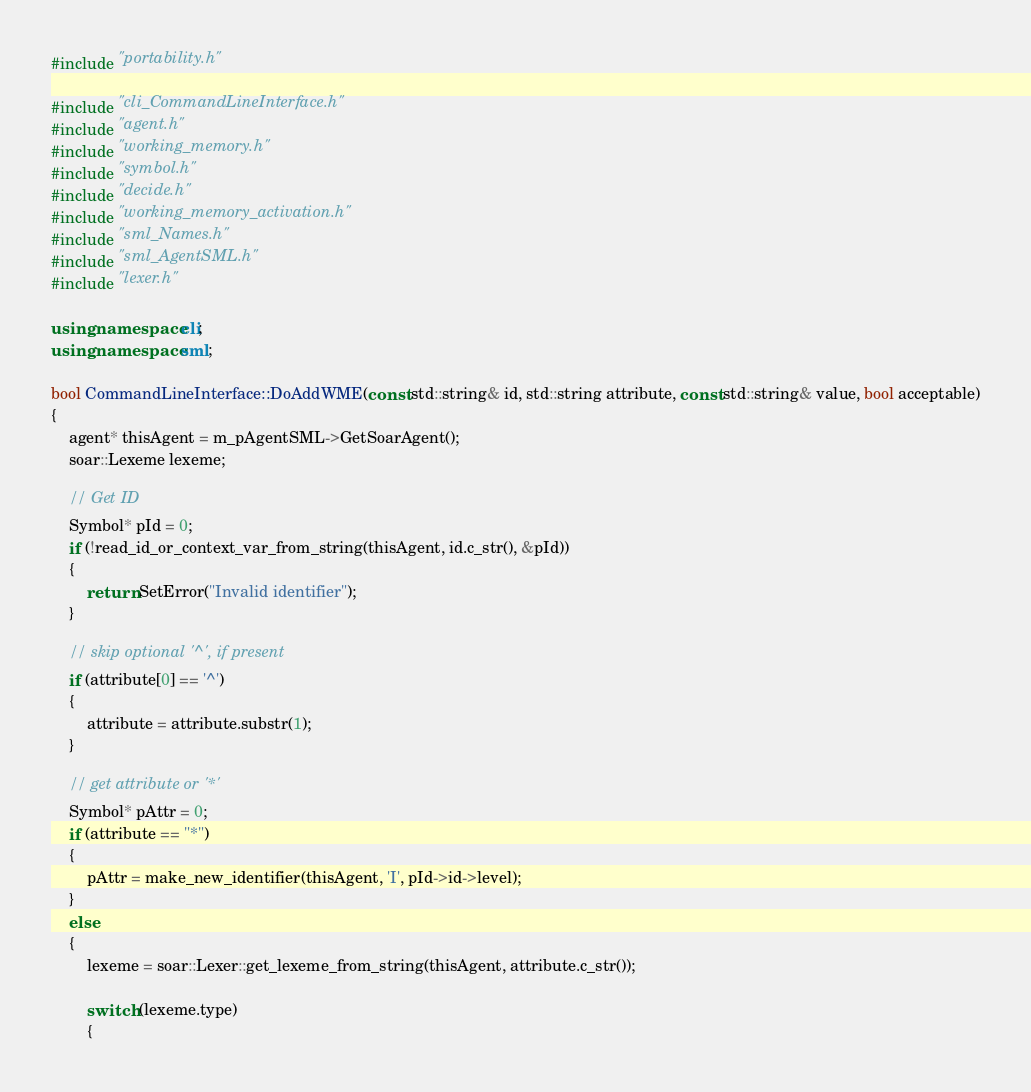Convert code to text. <code><loc_0><loc_0><loc_500><loc_500><_C++_>#include "portability.h"

#include "cli_CommandLineInterface.h"
#include "agent.h"
#include "working_memory.h"
#include "symbol.h"
#include "decide.h"
#include "working_memory_activation.h"
#include "sml_Names.h"
#include "sml_AgentSML.h"
#include "lexer.h"

using namespace cli;
using namespace sml;

bool CommandLineInterface::DoAddWME(const std::string& id, std::string attribute, const std::string& value, bool acceptable)
{
    agent* thisAgent = m_pAgentSML->GetSoarAgent();
    soar::Lexeme lexeme;

    // Get ID
    Symbol* pId = 0;
    if (!read_id_or_context_var_from_string(thisAgent, id.c_str(), &pId))
    {
        return SetError("Invalid identifier");
    }

    // skip optional '^', if present
    if (attribute[0] == '^')
    {
        attribute = attribute.substr(1);
    }

    // get attribute or '*'
    Symbol* pAttr = 0;
    if (attribute == "*")
    {
        pAttr = make_new_identifier(thisAgent, 'I', pId->id->level);
    }
    else
    {
        lexeme = soar::Lexer::get_lexeme_from_string(thisAgent, attribute.c_str());

        switch (lexeme.type)
        {</code> 